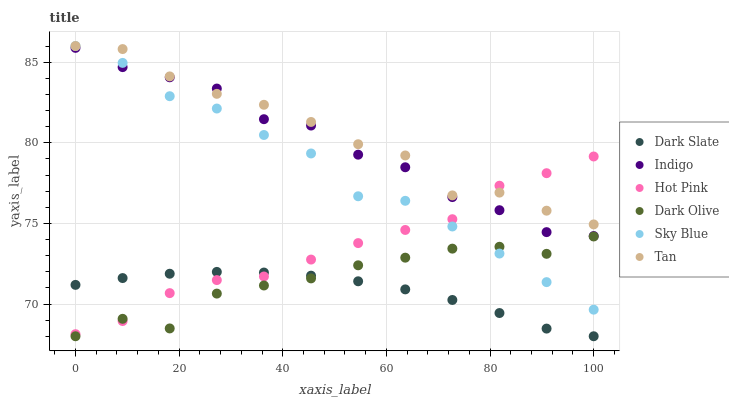Does Dark Slate have the minimum area under the curve?
Answer yes or no. Yes. Does Tan have the maximum area under the curve?
Answer yes or no. Yes. Does Indigo have the minimum area under the curve?
Answer yes or no. No. Does Indigo have the maximum area under the curve?
Answer yes or no. No. Is Dark Slate the smoothest?
Answer yes or no. Yes. Is Tan the roughest?
Answer yes or no. Yes. Is Indigo the smoothest?
Answer yes or no. No. Is Indigo the roughest?
Answer yes or no. No. Does Dark Olive have the lowest value?
Answer yes or no. Yes. Does Indigo have the lowest value?
Answer yes or no. No. Does Tan have the highest value?
Answer yes or no. Yes. Does Indigo have the highest value?
Answer yes or no. No. Is Dark Olive less than Indigo?
Answer yes or no. Yes. Is Indigo greater than Dark Olive?
Answer yes or no. Yes. Does Sky Blue intersect Indigo?
Answer yes or no. Yes. Is Sky Blue less than Indigo?
Answer yes or no. No. Is Sky Blue greater than Indigo?
Answer yes or no. No. Does Dark Olive intersect Indigo?
Answer yes or no. No. 